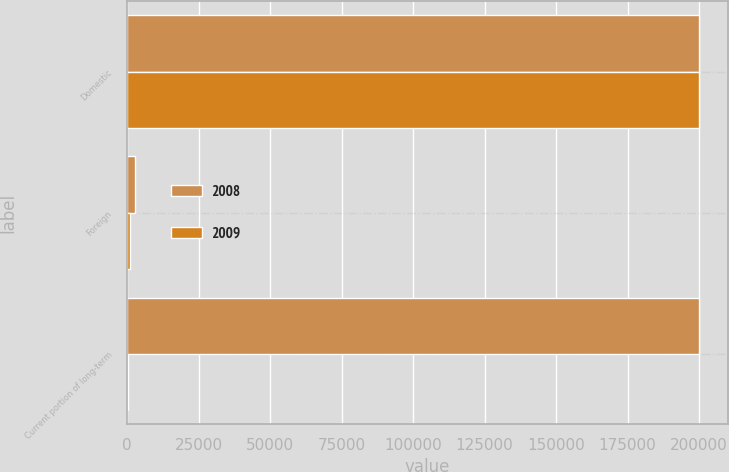Convert chart to OTSL. <chart><loc_0><loc_0><loc_500><loc_500><stacked_bar_chart><ecel><fcel>Domestic<fcel>Foreign<fcel>Current portion of long-term<nl><fcel>2008<fcel>200000<fcel>2880<fcel>200085<nl><fcel>2009<fcel>200000<fcel>992<fcel>320<nl></chart> 